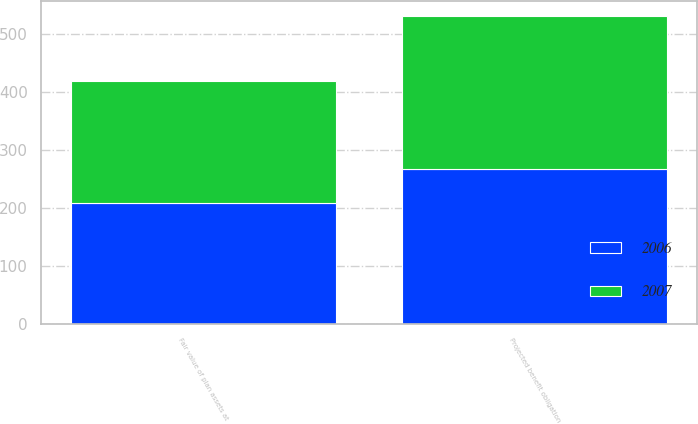<chart> <loc_0><loc_0><loc_500><loc_500><stacked_bar_chart><ecel><fcel>Projected benefit obligation<fcel>Fair value of plan assets at<nl><fcel>2007<fcel>264<fcel>210<nl><fcel>2006<fcel>266<fcel>208<nl></chart> 